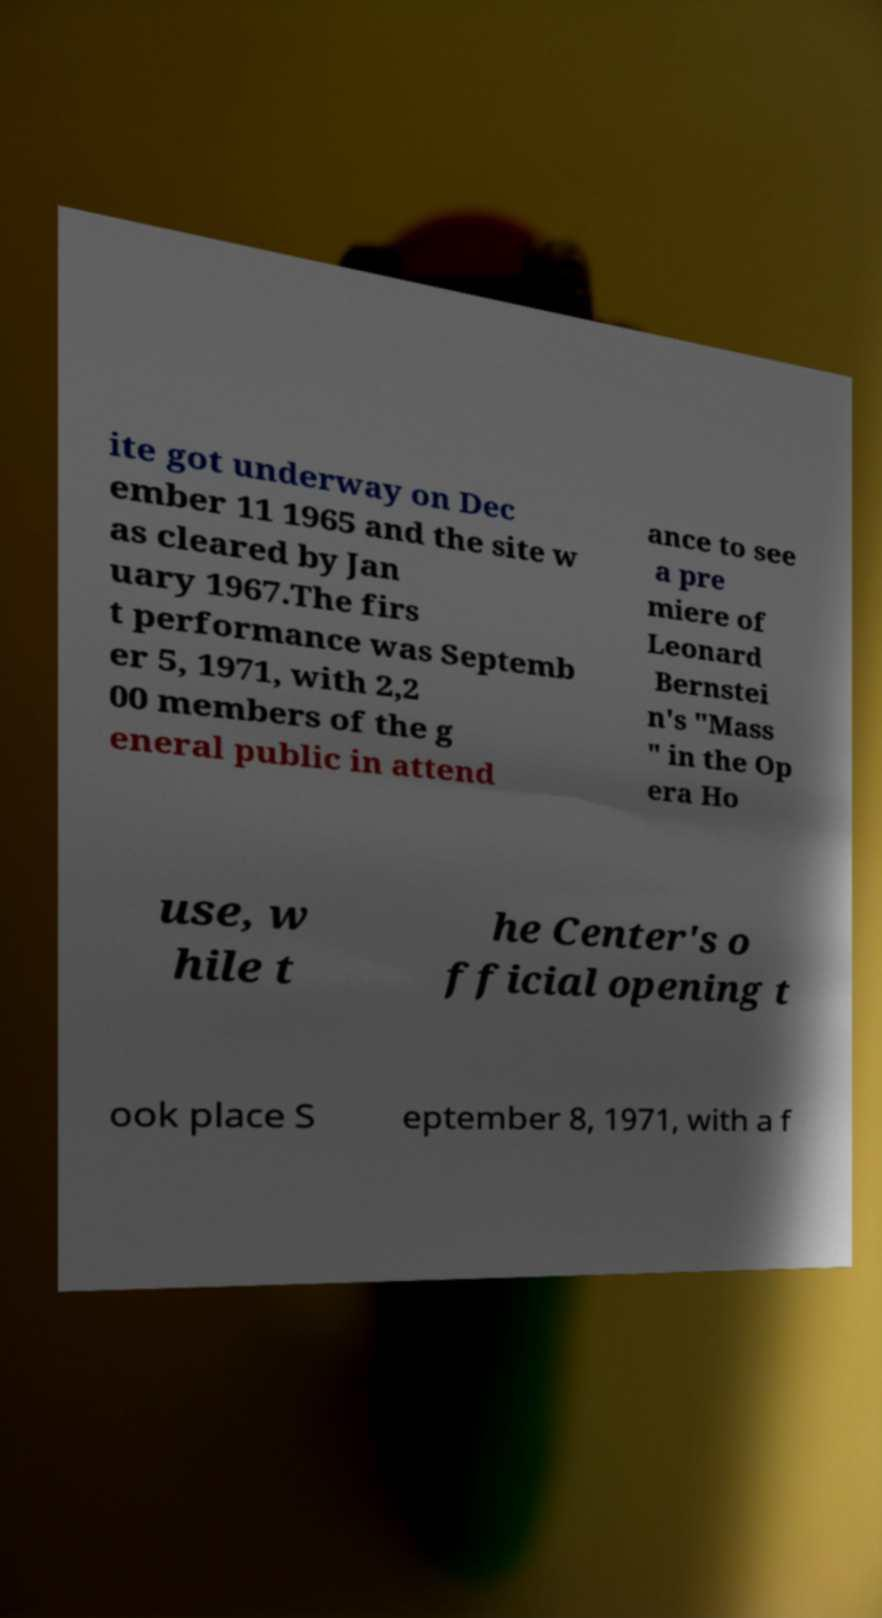Could you extract and type out the text from this image? ite got underway on Dec ember 11 1965 and the site w as cleared by Jan uary 1967.The firs t performance was Septemb er 5, 1971, with 2,2 00 members of the g eneral public in attend ance to see a pre miere of Leonard Bernstei n's "Mass " in the Op era Ho use, w hile t he Center's o fficial opening t ook place S eptember 8, 1971, with a f 